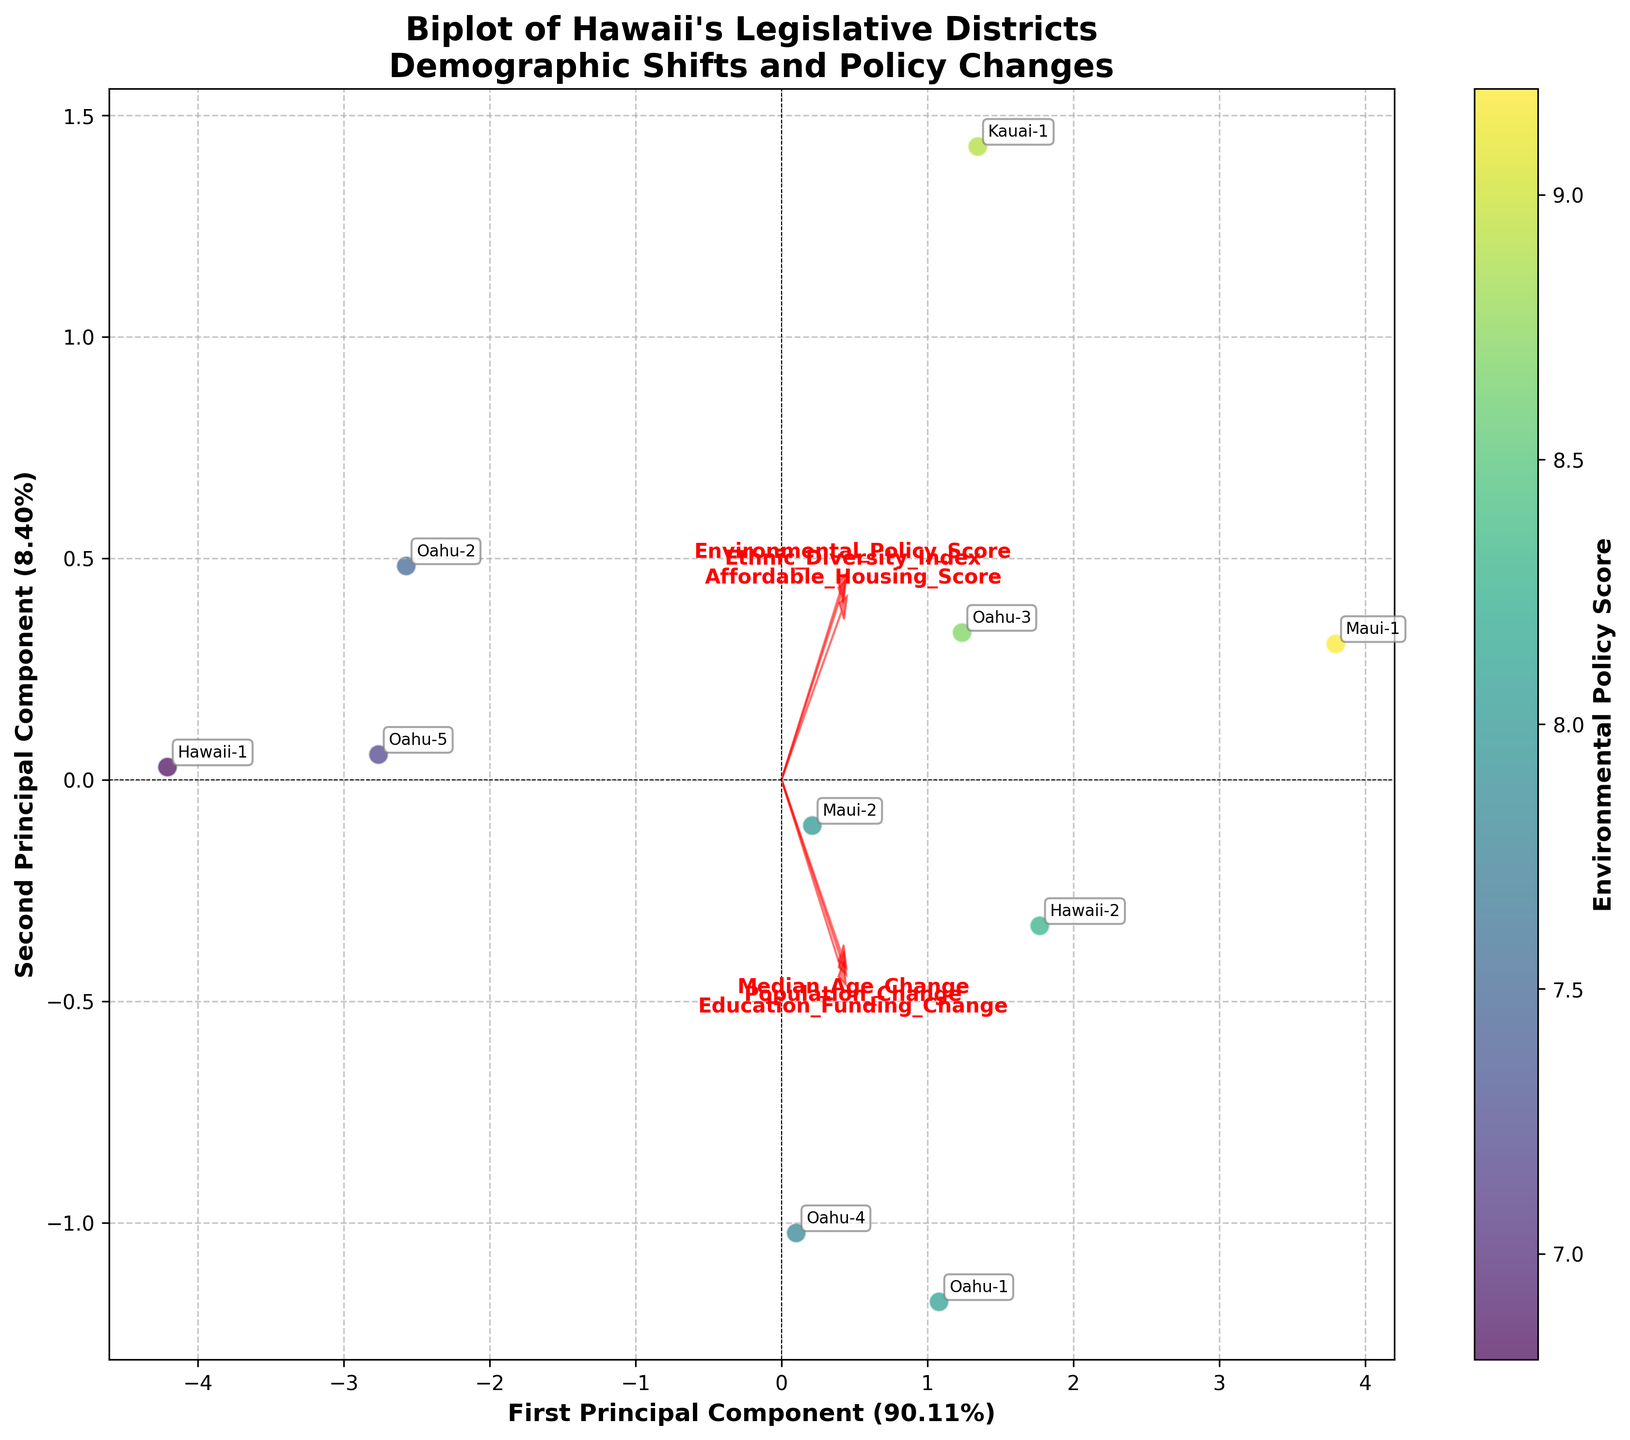What's the title of the plot? The title of the plot is a text element located at the top of the figure. It reads "Biplot of Hawaii's Legislative Districts\nDemographic Shifts and Policy Changes".
Answer: Biplot of Hawaii's Legislative Districts\nDemographic Shifts and Policy Changes How many principal components are shown in the biplot? The figure shows two principal components, as indicated by the axes labeled "First Principal Component" and "Second Principal Component".
Answer: Two Which variable is represented by the color of data points? The color gradient on the biplot is labeled "Environmental Policy Score", demonstrating that data point colors correspond to the Environmental Policy Score variable.
Answer: Environmental Policy Score Which district has the highest Environmental Policy Score? By examining the color scale and the colors of the points, the district with the highest score is Maui-1, as it is associated with the darkest hue.
Answer: Maui-1 What is the range of the Environmental Policy Score as shown in the figure? Referencing the colorbar labeled "Environmental Policy Score", the range spans from the lightest colors at the lower end (around 6.8) to the darkest colors at the higher end (around 9.2).
Answer: 6.8 to 9.2 Which districts have similar Population Change but different Median Age Change values? Districts Oahu-2 (-800 population change) and Oahu-5 (-500 population change) have negative population changes, yet Oahu-5 shows a different magnitude in median age change compared to Oahu-2.
Answer: Oahu-2 and Oahu-5 Which feature has the largest impact on the First Principal Component? The feature vectors (arrows) indicate impacts on principal components. The longest arrow along the First Principal Component suggests that "Education Funding Change" has the largest impact on it.
Answer: Education Funding Change Is there a strong relationship between Population Change and Education Funding Change in the biplot? By observing the feature vectors for Population Change and Education Funding Change, we notice that both arrows point in roughly the same direction, indicating a positive relationship.
Answer: Yes Which districts have median age changes greater than 1 year? Locating the "Median Age Change" feature vector, districts on the positive side of this vector would have such changes. This includes Oahu-1, Oahu-3, Oahu-4, Hawaii-2, and Maui-1.
Answer: Oahu-1, Oahu-3, Oahu-4, Hawaii-2, Maui-1 How do the Affordable Housing Scores compare between Oahu-1 and Hawaii-1? By finding the data points and labels for Oahu-1 and Hawaii-1, check their positions relative to the Affordable Housing Score vector. Oahu-1 is associated with a higher score than Hawaii-1.
Answer: Oahu-1 has a higher score than Hawaii-1 